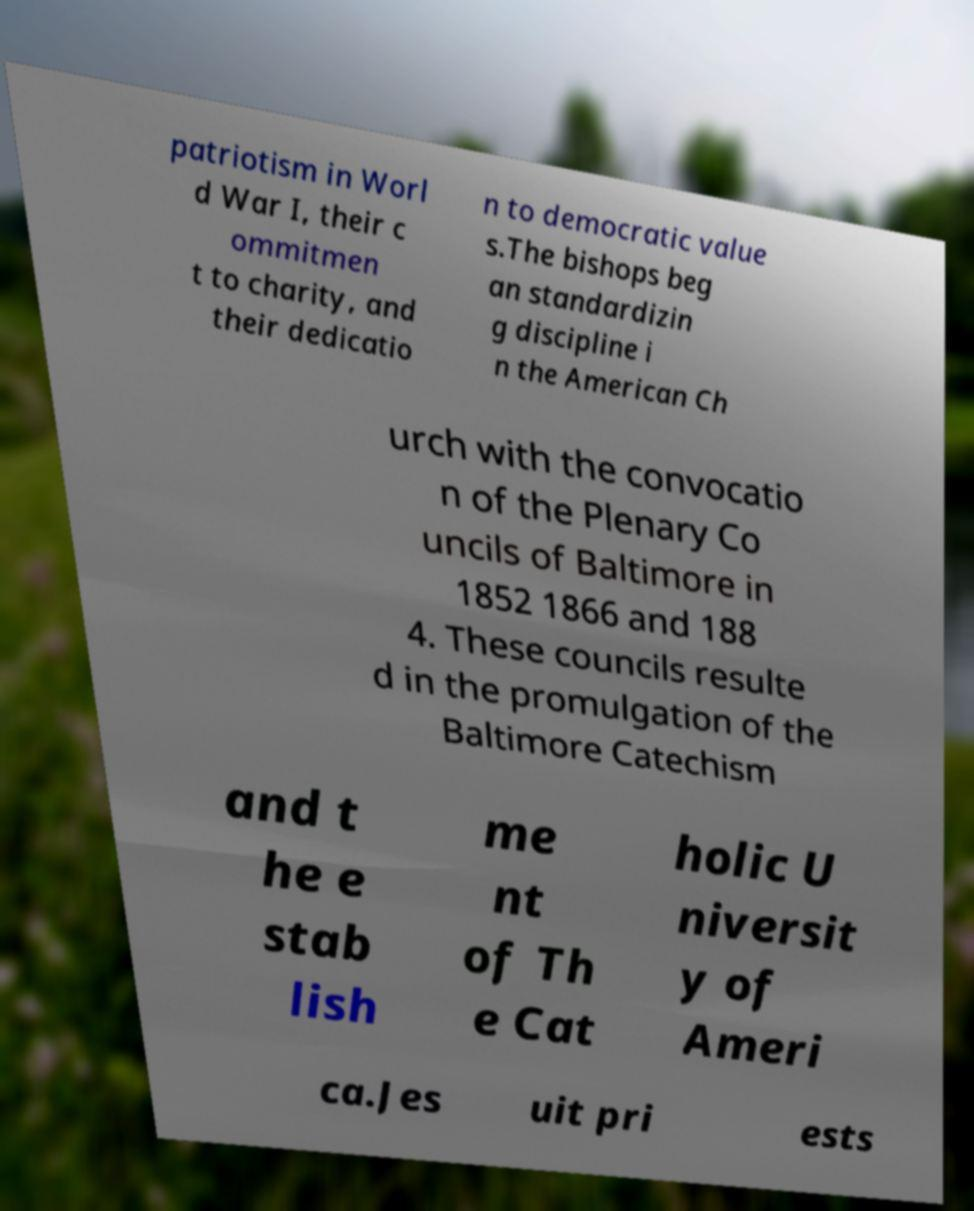Please read and relay the text visible in this image. What does it say? patriotism in Worl d War I, their c ommitmen t to charity, and their dedicatio n to democratic value s.The bishops beg an standardizin g discipline i n the American Ch urch with the convocatio n of the Plenary Co uncils of Baltimore in 1852 1866 and 188 4. These councils resulte d in the promulgation of the Baltimore Catechism and t he e stab lish me nt of Th e Cat holic U niversit y of Ameri ca.Jes uit pri ests 